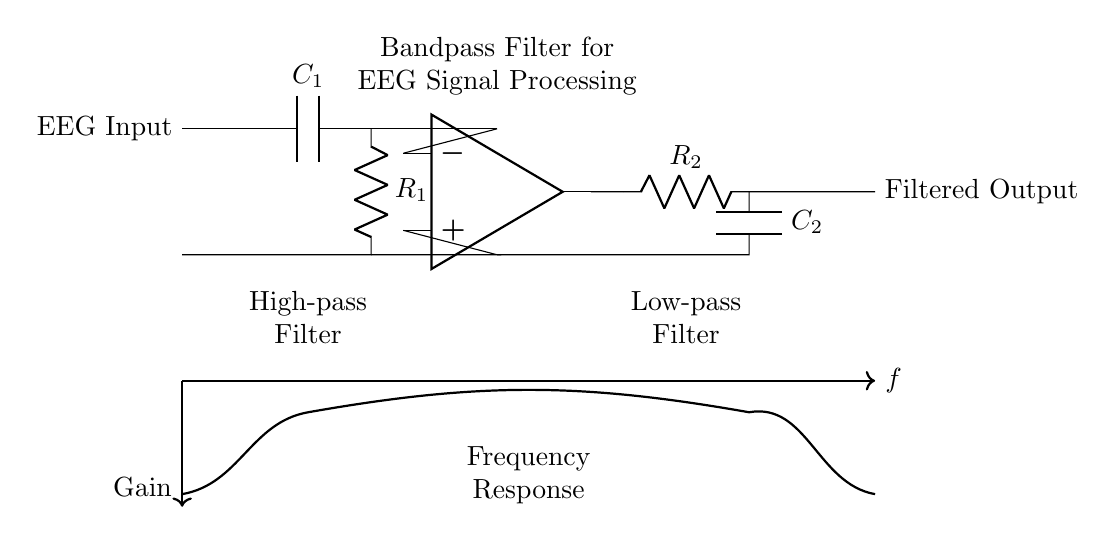What is the type of filter shown in the circuit? The circuit is a bandpass filter, which allows signals within a certain frequency range to pass while attenuating frequencies outside this range. The presence of both high-pass and low-pass filter sections indicates this characteristic.
Answer: bandpass filter How many resistors are in the circuit? There are two resistors in the circuit, labeled as R1 and R2. They are essential components of the high-pass and low-pass filter sections respectively.
Answer: two What does the capacitor labeled C1 do in this circuit? Capacitor C1, located in the high-pass filter section, blocks low-frequency signals and allows higher frequencies to pass through, thus setting the lower cutoff frequency of the bandpass filter.
Answer: blocks low frequencies What is the function of the operational amplifier in this circuit? The operational amplifier amplifies the difference in voltage between its inverting and non-inverting inputs, providing gain and helping to filter the signal after it passes through the R2-C2 path.
Answer: amplifies the signal What role does the second capacitor, C2, play in the circuit? Capacitor C2, situated in the low-pass filter section, allows low frequencies to pass while blocking high-frequency signals, establishing the upper cutoff frequency for the bandpass filter.
Answer: blocks high frequencies What are the labels of the input and output of the circuit? The input is labeled "EEG Input" and the output is labeled "Filtered Output," indicating where the EEG signal is processed and where the filtered signal emerges.
Answer: EEG Input, Filtered Output 